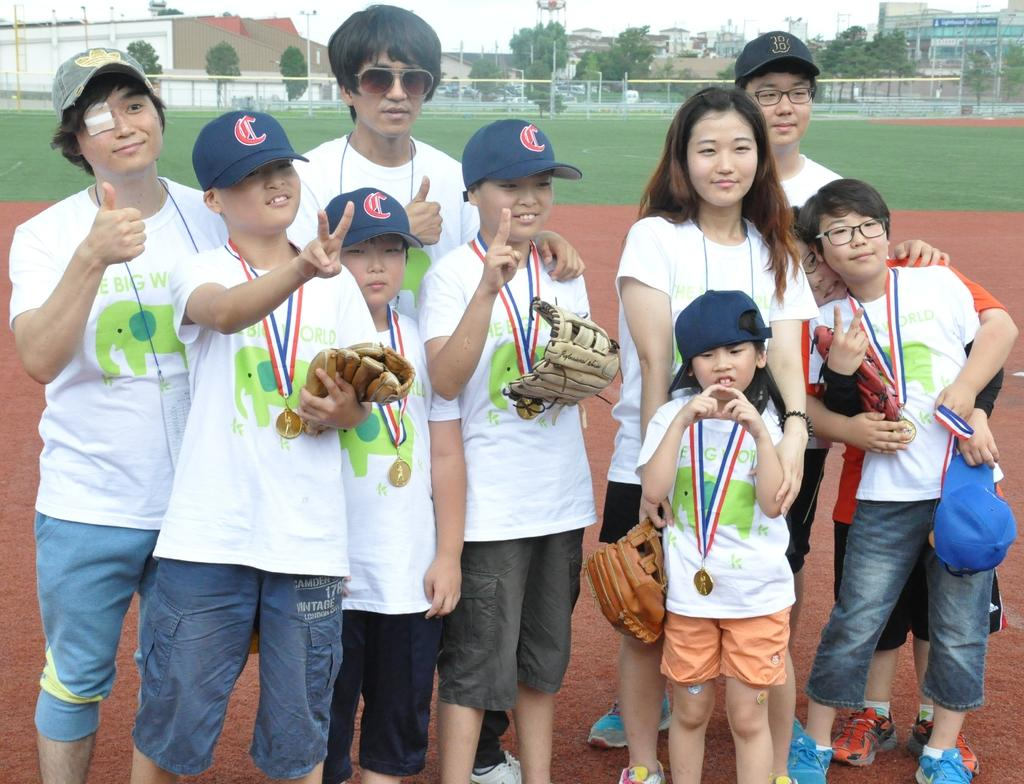How many people are in the image? There is a group of people in the image, but the exact number is not specified. What are some people holding in the image? Some people are holding objects, but the specific objects are not described. What can be seen in the background of the image? In the background of the image, there is grass, poles, trees, buildings, walls, "few things," and the sky. Can you describe the setting of the image? The image appears to be set outdoors, with a variety of natural and man-made elements visible in the background. What type of bun is being used to hold the thread in the image? There is no bun or thread present in the image. Can you describe the curve of the object being held by one of the people in the image? The facts do not specify any details about the objects being held by the people in the image, so we cannot describe their shape or curvature. 